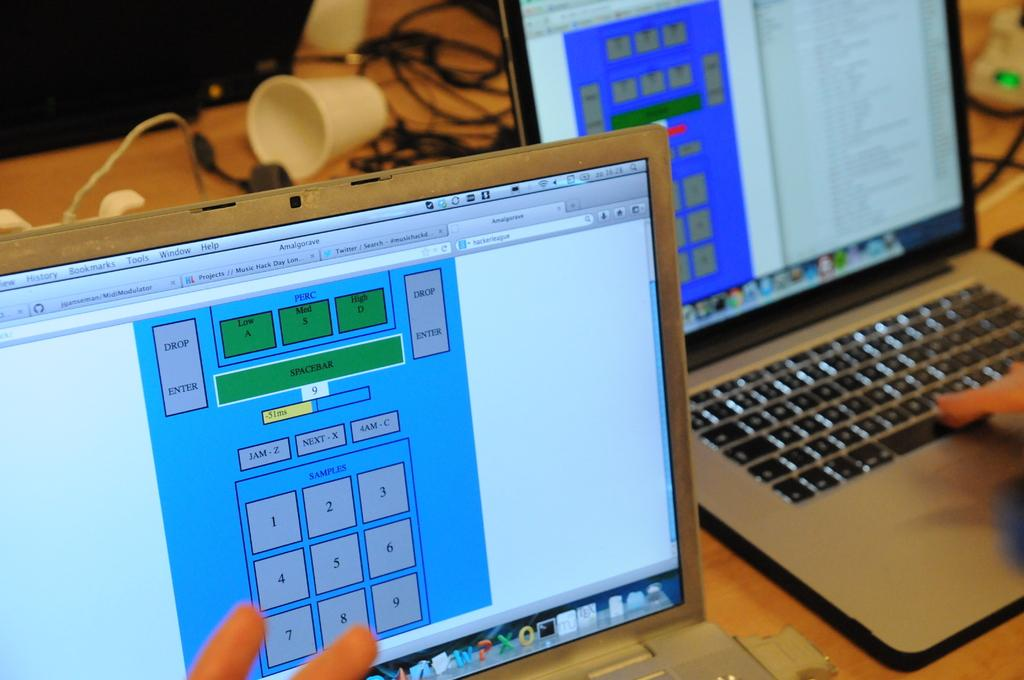<image>
Create a compact narrative representing the image presented. A finger rests near the number 8 on the number samples shown on the screen. 